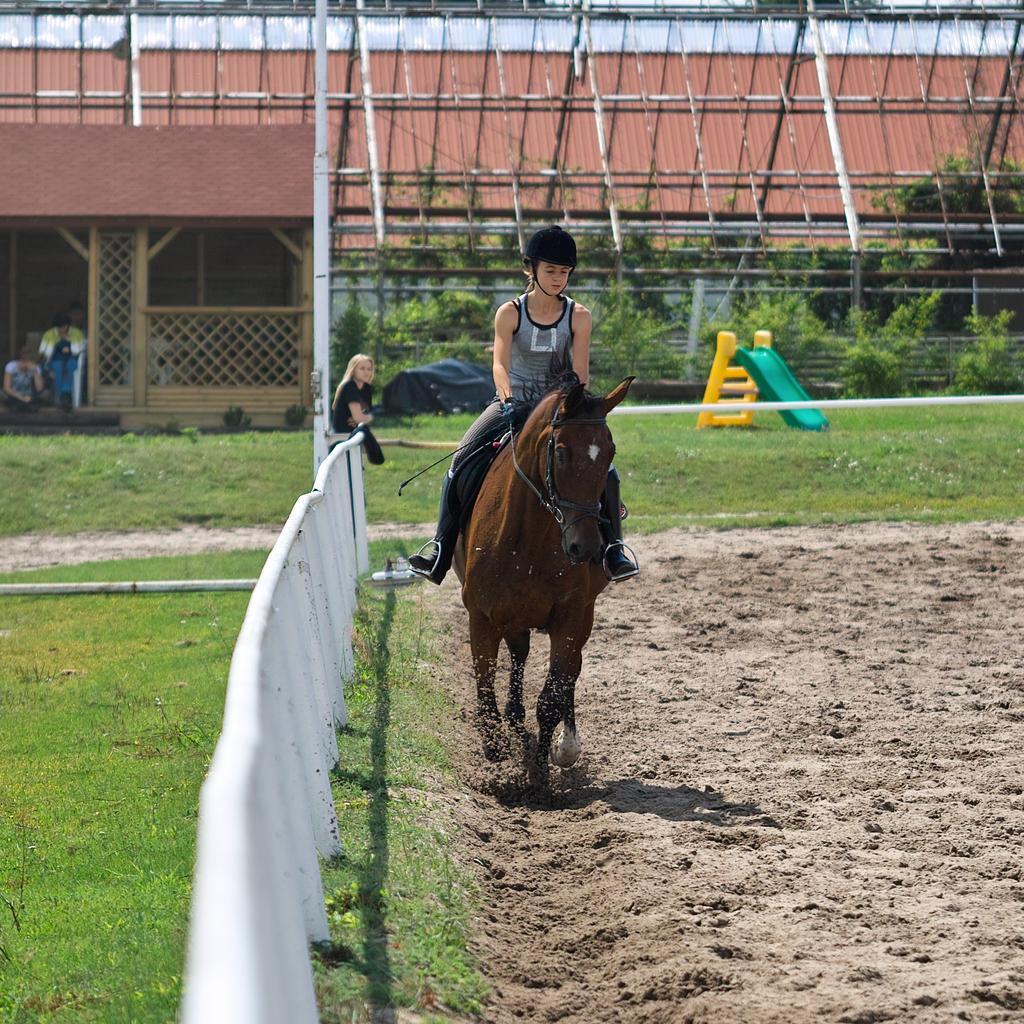How would you summarize this image in a sentence or two? In the picture we can see a muddy surface on it, we can see a person riding the horse and beside it, we can see a railing on the grass surface and in the background, we can see a shed and some plants near it on the path and some persons also sitting and one person is standing. 